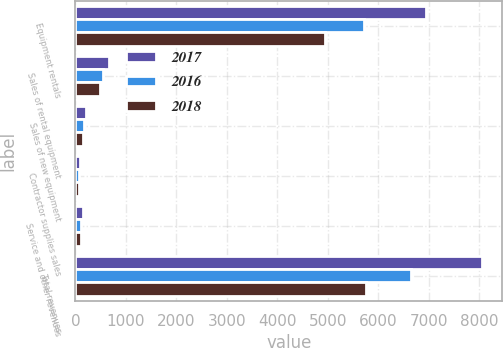Convert chart to OTSL. <chart><loc_0><loc_0><loc_500><loc_500><stacked_bar_chart><ecel><fcel>Equipment rentals<fcel>Sales of rental equipment<fcel>Sales of new equipment<fcel>Contractor supplies sales<fcel>Service and other revenues<fcel>Total revenues<nl><fcel>2017<fcel>6940<fcel>664<fcel>208<fcel>91<fcel>144<fcel>8047<nl><fcel>2016<fcel>5715<fcel>550<fcel>178<fcel>80<fcel>118<fcel>6641<nl><fcel>2018<fcel>4941<fcel>496<fcel>144<fcel>79<fcel>102<fcel>5762<nl></chart> 